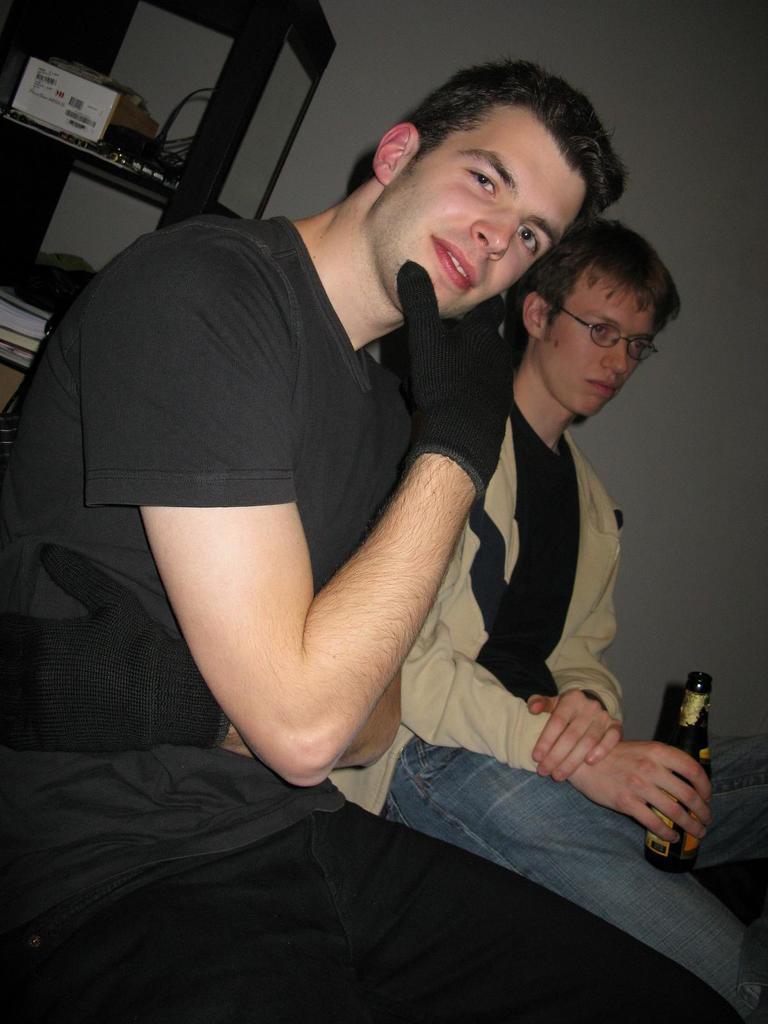In one or two sentences, can you explain what this image depicts? In this image I see 2 men who are sitting and this man is holding a bottle in his hand. In the background I see the rack and there are few things in it and I can also see the wall. 